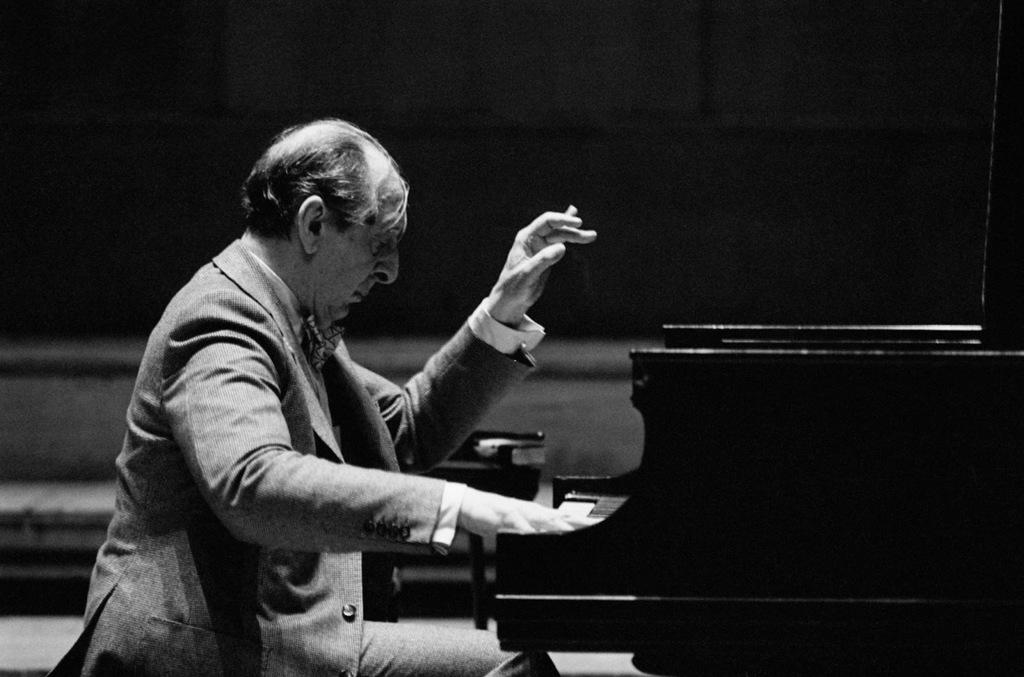What is the main subject of the image? There is a person in the image. What is the person doing in the image? The person is playing a piano. What is the person sitting on while playing the piano? The person is sitting on a chair. What direction is the donkey facing in the image? There is no donkey present in the image. 